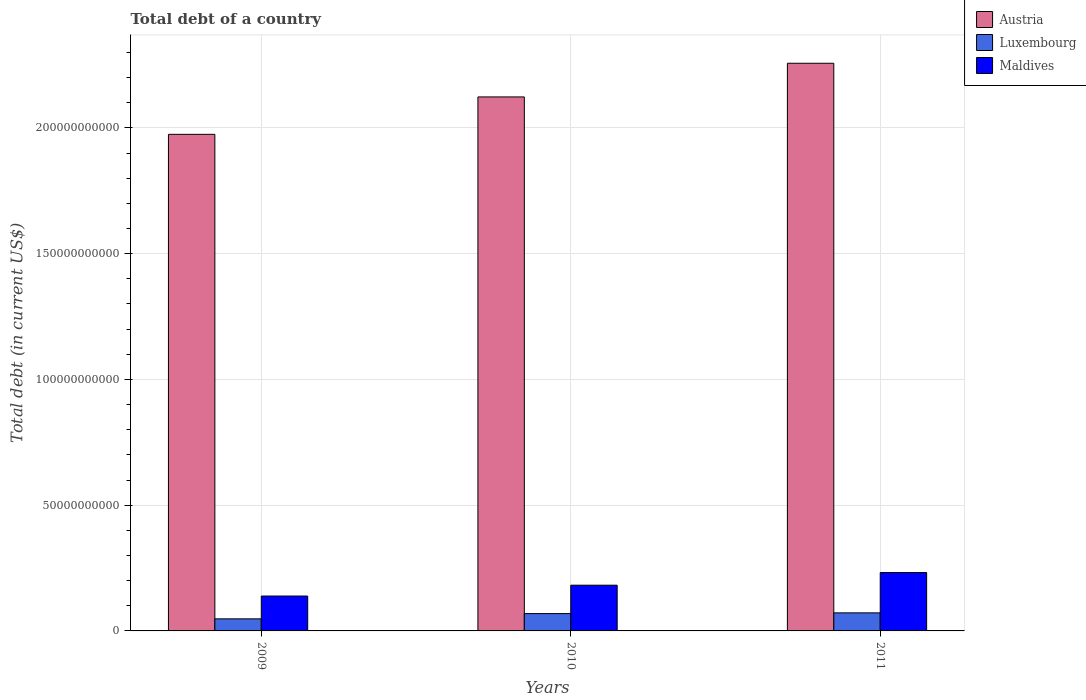How many different coloured bars are there?
Give a very brief answer. 3. Are the number of bars per tick equal to the number of legend labels?
Ensure brevity in your answer.  Yes. Are the number of bars on each tick of the X-axis equal?
Offer a terse response. Yes. How many bars are there on the 2nd tick from the right?
Ensure brevity in your answer.  3. In how many cases, is the number of bars for a given year not equal to the number of legend labels?
Offer a very short reply. 0. What is the debt in Luxembourg in 2011?
Your answer should be compact. 7.18e+09. Across all years, what is the maximum debt in Luxembourg?
Your answer should be very brief. 7.18e+09. Across all years, what is the minimum debt in Maldives?
Offer a terse response. 1.39e+1. In which year was the debt in Austria maximum?
Offer a very short reply. 2011. In which year was the debt in Maldives minimum?
Your answer should be very brief. 2009. What is the total debt in Maldives in the graph?
Offer a terse response. 5.53e+1. What is the difference between the debt in Luxembourg in 2010 and that in 2011?
Provide a succinct answer. -2.83e+08. What is the difference between the debt in Luxembourg in 2011 and the debt in Maldives in 2009?
Keep it short and to the point. -6.69e+09. What is the average debt in Luxembourg per year?
Keep it short and to the point. 6.29e+09. In the year 2011, what is the difference between the debt in Maldives and debt in Austria?
Give a very brief answer. -2.02e+11. What is the ratio of the debt in Luxembourg in 2009 to that in 2010?
Offer a very short reply. 0.7. Is the difference between the debt in Maldives in 2009 and 2011 greater than the difference between the debt in Austria in 2009 and 2011?
Make the answer very short. Yes. What is the difference between the highest and the second highest debt in Maldives?
Make the answer very short. 5.03e+09. What is the difference between the highest and the lowest debt in Luxembourg?
Provide a short and direct response. 2.38e+09. Is the sum of the debt in Austria in 2009 and 2011 greater than the maximum debt in Maldives across all years?
Your answer should be compact. Yes. What does the 3rd bar from the left in 2010 represents?
Your response must be concise. Maldives. What does the 1st bar from the right in 2009 represents?
Your response must be concise. Maldives. Is it the case that in every year, the sum of the debt in Luxembourg and debt in Maldives is greater than the debt in Austria?
Ensure brevity in your answer.  No. How many bars are there?
Give a very brief answer. 9. How many years are there in the graph?
Your answer should be very brief. 3. What is the difference between two consecutive major ticks on the Y-axis?
Your response must be concise. 5.00e+1. Are the values on the major ticks of Y-axis written in scientific E-notation?
Your answer should be very brief. No. Does the graph contain any zero values?
Give a very brief answer. No. Does the graph contain grids?
Your answer should be compact. Yes. Where does the legend appear in the graph?
Your answer should be compact. Top right. How many legend labels are there?
Your response must be concise. 3. What is the title of the graph?
Keep it short and to the point. Total debt of a country. What is the label or title of the Y-axis?
Provide a succinct answer. Total debt (in current US$). What is the Total debt (in current US$) of Austria in 2009?
Your response must be concise. 1.97e+11. What is the Total debt (in current US$) of Luxembourg in 2009?
Make the answer very short. 4.80e+09. What is the Total debt (in current US$) of Maldives in 2009?
Your answer should be compact. 1.39e+1. What is the Total debt (in current US$) in Austria in 2010?
Keep it short and to the point. 2.12e+11. What is the Total debt (in current US$) of Luxembourg in 2010?
Your answer should be compact. 6.89e+09. What is the Total debt (in current US$) of Maldives in 2010?
Your response must be concise. 1.82e+1. What is the Total debt (in current US$) of Austria in 2011?
Your response must be concise. 2.26e+11. What is the Total debt (in current US$) in Luxembourg in 2011?
Offer a terse response. 7.18e+09. What is the Total debt (in current US$) in Maldives in 2011?
Your answer should be compact. 2.32e+1. Across all years, what is the maximum Total debt (in current US$) of Austria?
Provide a short and direct response. 2.26e+11. Across all years, what is the maximum Total debt (in current US$) of Luxembourg?
Offer a very short reply. 7.18e+09. Across all years, what is the maximum Total debt (in current US$) in Maldives?
Your answer should be very brief. 2.32e+1. Across all years, what is the minimum Total debt (in current US$) in Austria?
Offer a terse response. 1.97e+11. Across all years, what is the minimum Total debt (in current US$) of Luxembourg?
Offer a very short reply. 4.80e+09. Across all years, what is the minimum Total debt (in current US$) in Maldives?
Give a very brief answer. 1.39e+1. What is the total Total debt (in current US$) of Austria in the graph?
Provide a succinct answer. 6.35e+11. What is the total Total debt (in current US$) of Luxembourg in the graph?
Offer a terse response. 1.89e+1. What is the total Total debt (in current US$) in Maldives in the graph?
Make the answer very short. 5.53e+1. What is the difference between the Total debt (in current US$) of Austria in 2009 and that in 2010?
Offer a very short reply. -1.49e+1. What is the difference between the Total debt (in current US$) in Luxembourg in 2009 and that in 2010?
Make the answer very short. -2.10e+09. What is the difference between the Total debt (in current US$) in Maldives in 2009 and that in 2010?
Your answer should be compact. -4.32e+09. What is the difference between the Total debt (in current US$) in Austria in 2009 and that in 2011?
Provide a succinct answer. -2.83e+1. What is the difference between the Total debt (in current US$) in Luxembourg in 2009 and that in 2011?
Make the answer very short. -2.38e+09. What is the difference between the Total debt (in current US$) of Maldives in 2009 and that in 2011?
Provide a short and direct response. -9.34e+09. What is the difference between the Total debt (in current US$) of Austria in 2010 and that in 2011?
Give a very brief answer. -1.34e+1. What is the difference between the Total debt (in current US$) of Luxembourg in 2010 and that in 2011?
Provide a short and direct response. -2.83e+08. What is the difference between the Total debt (in current US$) of Maldives in 2010 and that in 2011?
Offer a terse response. -5.03e+09. What is the difference between the Total debt (in current US$) in Austria in 2009 and the Total debt (in current US$) in Luxembourg in 2010?
Provide a succinct answer. 1.91e+11. What is the difference between the Total debt (in current US$) of Austria in 2009 and the Total debt (in current US$) of Maldives in 2010?
Give a very brief answer. 1.79e+11. What is the difference between the Total debt (in current US$) in Luxembourg in 2009 and the Total debt (in current US$) in Maldives in 2010?
Make the answer very short. -1.34e+1. What is the difference between the Total debt (in current US$) of Austria in 2009 and the Total debt (in current US$) of Luxembourg in 2011?
Ensure brevity in your answer.  1.90e+11. What is the difference between the Total debt (in current US$) of Austria in 2009 and the Total debt (in current US$) of Maldives in 2011?
Offer a very short reply. 1.74e+11. What is the difference between the Total debt (in current US$) of Luxembourg in 2009 and the Total debt (in current US$) of Maldives in 2011?
Offer a very short reply. -1.84e+1. What is the difference between the Total debt (in current US$) of Austria in 2010 and the Total debt (in current US$) of Luxembourg in 2011?
Keep it short and to the point. 2.05e+11. What is the difference between the Total debt (in current US$) in Austria in 2010 and the Total debt (in current US$) in Maldives in 2011?
Ensure brevity in your answer.  1.89e+11. What is the difference between the Total debt (in current US$) of Luxembourg in 2010 and the Total debt (in current US$) of Maldives in 2011?
Ensure brevity in your answer.  -1.63e+1. What is the average Total debt (in current US$) of Austria per year?
Offer a very short reply. 2.12e+11. What is the average Total debt (in current US$) of Luxembourg per year?
Your response must be concise. 6.29e+09. What is the average Total debt (in current US$) in Maldives per year?
Keep it short and to the point. 1.84e+1. In the year 2009, what is the difference between the Total debt (in current US$) of Austria and Total debt (in current US$) of Luxembourg?
Offer a terse response. 1.93e+11. In the year 2009, what is the difference between the Total debt (in current US$) in Austria and Total debt (in current US$) in Maldives?
Provide a succinct answer. 1.84e+11. In the year 2009, what is the difference between the Total debt (in current US$) in Luxembourg and Total debt (in current US$) in Maldives?
Offer a terse response. -9.07e+09. In the year 2010, what is the difference between the Total debt (in current US$) of Austria and Total debt (in current US$) of Luxembourg?
Offer a terse response. 2.05e+11. In the year 2010, what is the difference between the Total debt (in current US$) in Austria and Total debt (in current US$) in Maldives?
Offer a very short reply. 1.94e+11. In the year 2010, what is the difference between the Total debt (in current US$) in Luxembourg and Total debt (in current US$) in Maldives?
Your answer should be compact. -1.13e+1. In the year 2011, what is the difference between the Total debt (in current US$) of Austria and Total debt (in current US$) of Luxembourg?
Provide a succinct answer. 2.19e+11. In the year 2011, what is the difference between the Total debt (in current US$) in Austria and Total debt (in current US$) in Maldives?
Offer a terse response. 2.02e+11. In the year 2011, what is the difference between the Total debt (in current US$) of Luxembourg and Total debt (in current US$) of Maldives?
Give a very brief answer. -1.60e+1. What is the ratio of the Total debt (in current US$) in Austria in 2009 to that in 2010?
Your answer should be compact. 0.93. What is the ratio of the Total debt (in current US$) of Luxembourg in 2009 to that in 2010?
Make the answer very short. 0.7. What is the ratio of the Total debt (in current US$) of Maldives in 2009 to that in 2010?
Keep it short and to the point. 0.76. What is the ratio of the Total debt (in current US$) in Austria in 2009 to that in 2011?
Provide a short and direct response. 0.87. What is the ratio of the Total debt (in current US$) of Luxembourg in 2009 to that in 2011?
Your response must be concise. 0.67. What is the ratio of the Total debt (in current US$) of Maldives in 2009 to that in 2011?
Keep it short and to the point. 0.6. What is the ratio of the Total debt (in current US$) of Austria in 2010 to that in 2011?
Your answer should be compact. 0.94. What is the ratio of the Total debt (in current US$) in Luxembourg in 2010 to that in 2011?
Provide a succinct answer. 0.96. What is the ratio of the Total debt (in current US$) of Maldives in 2010 to that in 2011?
Provide a short and direct response. 0.78. What is the difference between the highest and the second highest Total debt (in current US$) of Austria?
Make the answer very short. 1.34e+1. What is the difference between the highest and the second highest Total debt (in current US$) in Luxembourg?
Provide a short and direct response. 2.83e+08. What is the difference between the highest and the second highest Total debt (in current US$) in Maldives?
Provide a short and direct response. 5.03e+09. What is the difference between the highest and the lowest Total debt (in current US$) of Austria?
Provide a succinct answer. 2.83e+1. What is the difference between the highest and the lowest Total debt (in current US$) of Luxembourg?
Keep it short and to the point. 2.38e+09. What is the difference between the highest and the lowest Total debt (in current US$) in Maldives?
Provide a short and direct response. 9.34e+09. 